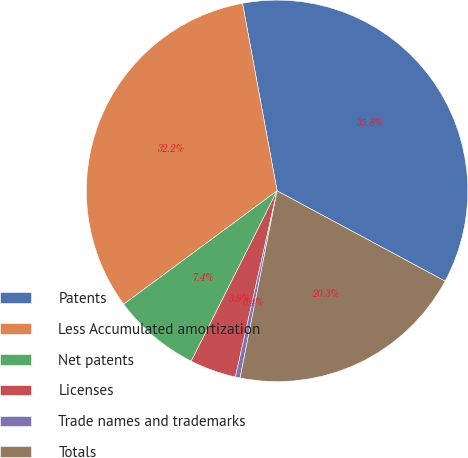Convert chart to OTSL. <chart><loc_0><loc_0><loc_500><loc_500><pie_chart><fcel>Patents<fcel>Less Accumulated amortization<fcel>Net patents<fcel>Licenses<fcel>Trade names and trademarks<fcel>Totals<nl><fcel>35.75%<fcel>32.23%<fcel>7.44%<fcel>3.92%<fcel>0.4%<fcel>20.26%<nl></chart> 